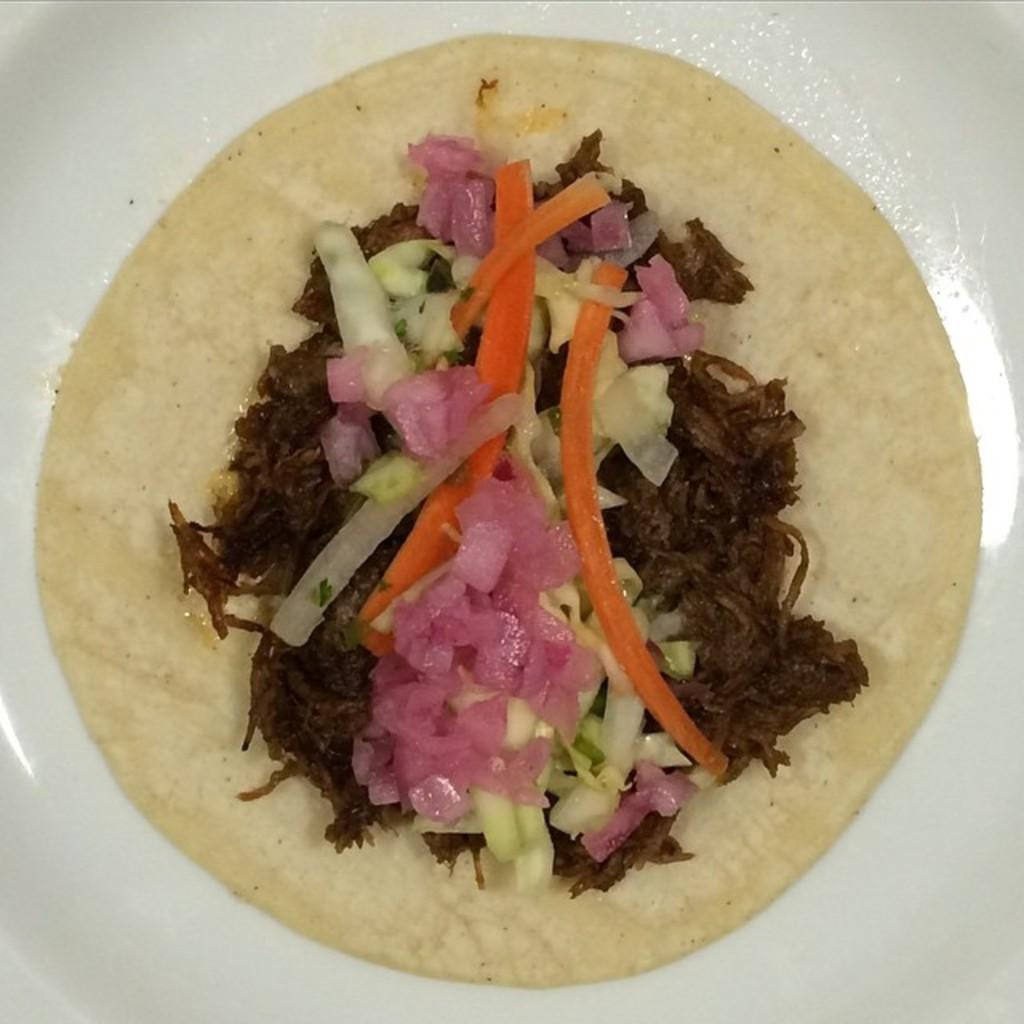What is on the plate in the image? There is a plate in the image, and it contains food. What specific ingredients are present in the food on the plate? The food contains onions, cabbage, and carrots. How many birds are sitting on the floor near the plate in the image? There are no birds present in the image; it only shows a white plate with food on it. 